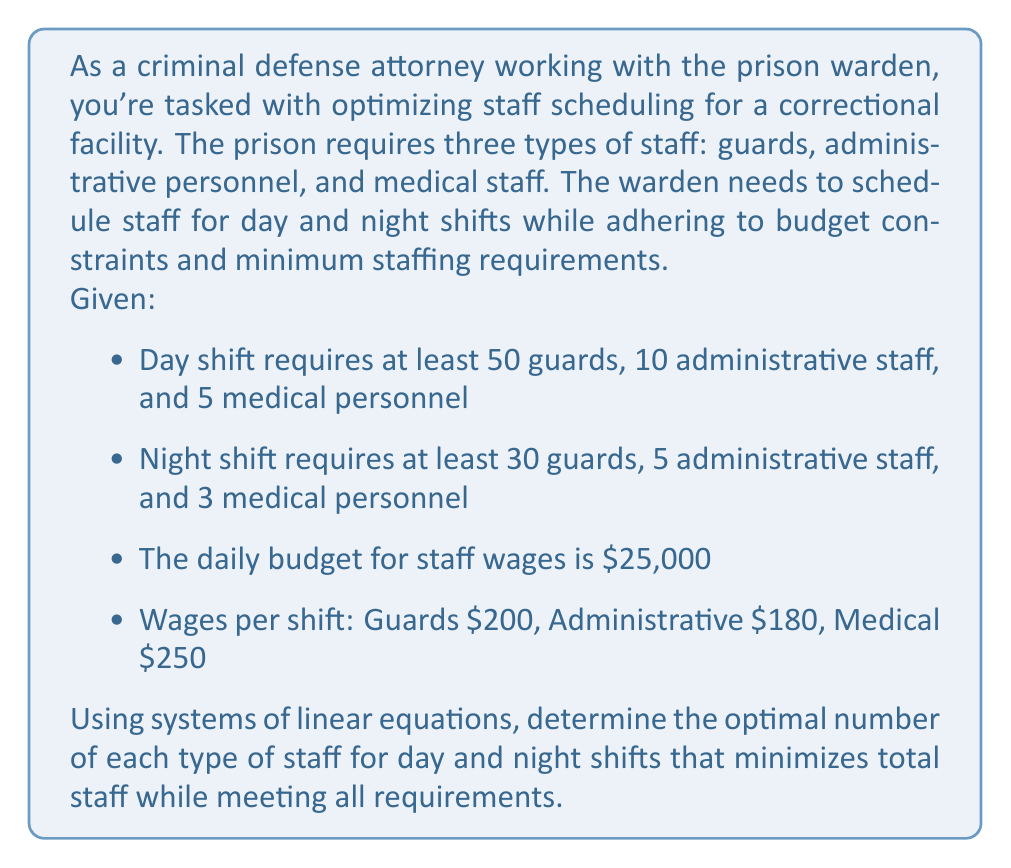Give your solution to this math problem. Let's approach this step-by-step using linear algebra:

1) Define variables:
   $x_1$ = number of guards on day shift
   $x_2$ = number of administrative staff on day shift
   $x_3$ = number of medical staff on day shift
   $y_1$ = number of guards on night shift
   $y_2$ = number of administrative staff on night shift
   $y_3$ = number of medical staff on night shift

2) Set up inequalities for minimum staffing requirements:
   Day shift: $x_1 \geq 50$, $x_2 \geq 10$, $x_3 \geq 5$
   Night shift: $y_1 \geq 30$, $y_2 \geq 5$, $y_3 \geq 3$

3) Set up equation for budget constraint:
   $200(x_1 + y_1) + 180(x_2 + y_2) + 250(x_3 + y_3) \leq 25000$

4) Objective function to minimize total staff:
   Minimize $Z = x_1 + x_2 + x_3 + y_1 + y_2 + y_3$

5) Solve using linear programming methods. The optimal solution will be at the intersection of the constraints. We can start by setting each variable to its minimum required value:

   $x_1 = 50$, $x_2 = 10$, $x_3 = 5$
   $y_1 = 30$, $y_2 = 5$, $y_3 = 3$

6) Check if this solution satisfies the budget constraint:
   $200(50 + 30) + 180(10 + 5) + 250(5 + 3) = 16000 + 2700 + 2000 = 20700$

   This is under the $25000 budget, so it's a feasible solution.

7) Since we've met all minimum requirements and are under budget, this is the optimal solution that minimizes total staff.
Answer: The optimal staffing solution is:
Day shift: 50 guards, 10 administrative staff, 5 medical staff
Night shift: 30 guards, 5 administrative staff, 3 medical staff
Total staff: 103
Total cost: $20,700 